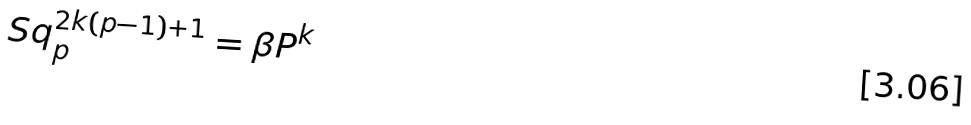Convert formula to latex. <formula><loc_0><loc_0><loc_500><loc_500>S q _ { p } ^ { 2 k ( p - 1 ) + 1 } = \beta P ^ { k }</formula> 